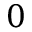Convert formula to latex. <formula><loc_0><loc_0><loc_500><loc_500>0</formula> 